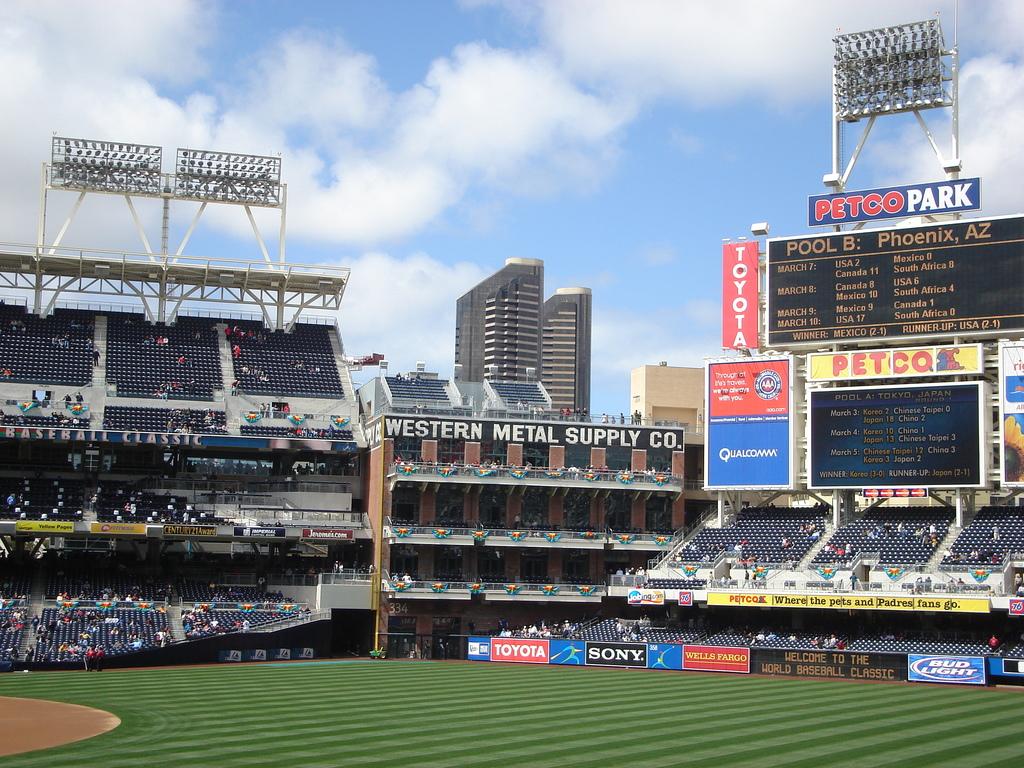What is the name of the baseball stadium?
Offer a very short reply. Petco park. What car company sponsors this field?
Your response must be concise. Toyota. 